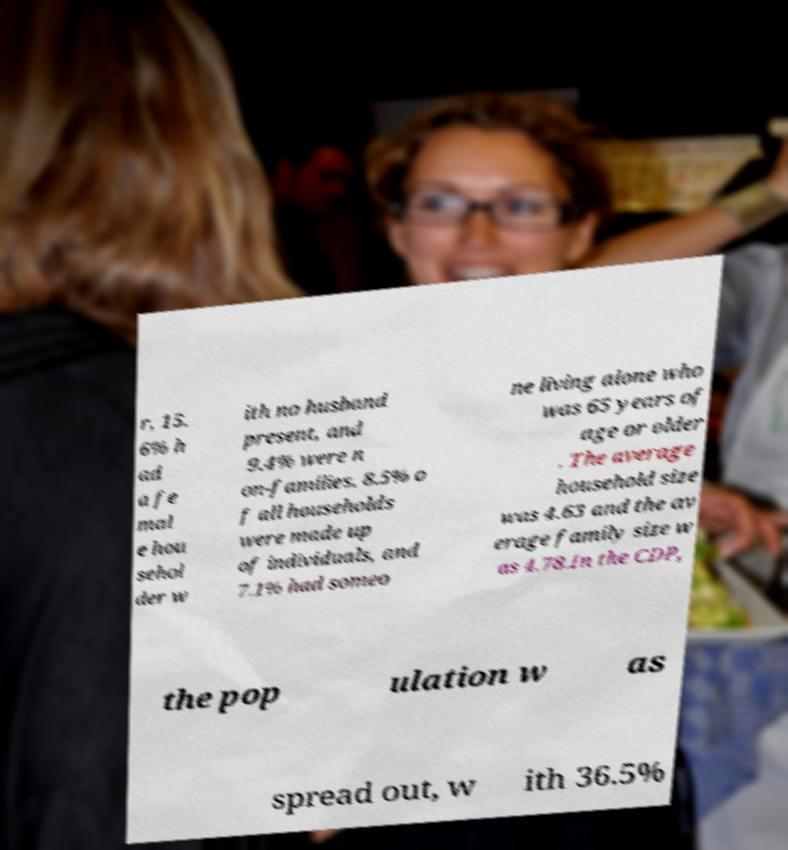Please identify and transcribe the text found in this image. r, 15. 6% h ad a fe mal e hou sehol der w ith no husband present, and 9.4% were n on-families. 8.5% o f all households were made up of individuals, and 7.1% had someo ne living alone who was 65 years of age or older . The average household size was 4.63 and the av erage family size w as 4.78.In the CDP, the pop ulation w as spread out, w ith 36.5% 